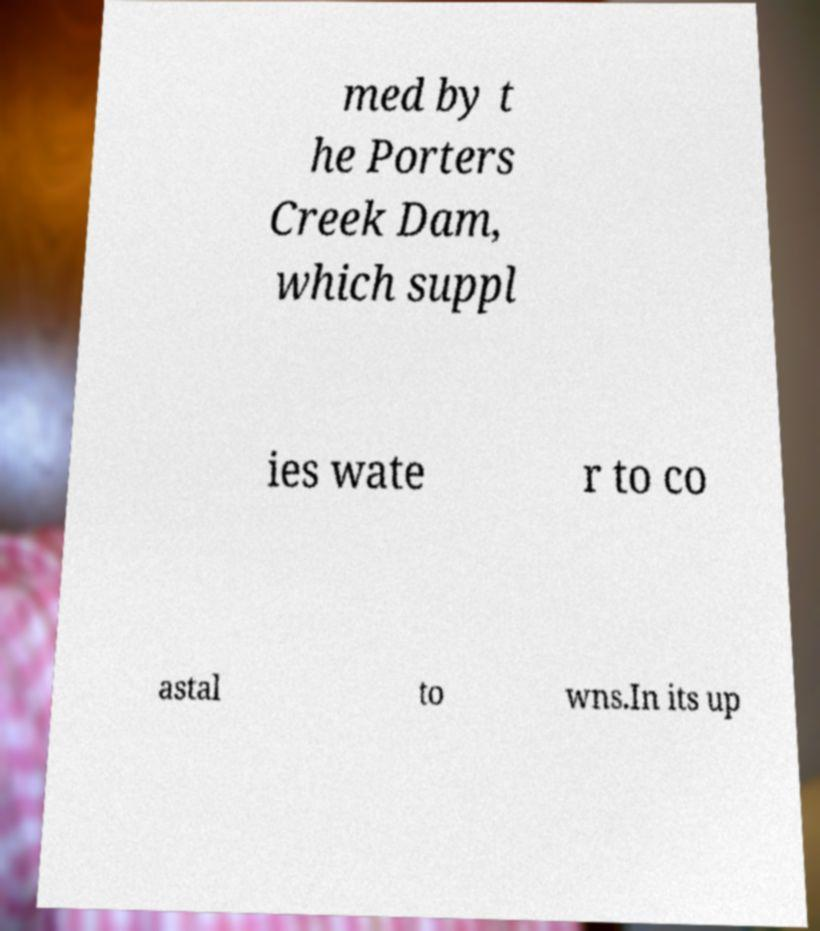There's text embedded in this image that I need extracted. Can you transcribe it verbatim? med by t he Porters Creek Dam, which suppl ies wate r to co astal to wns.In its up 